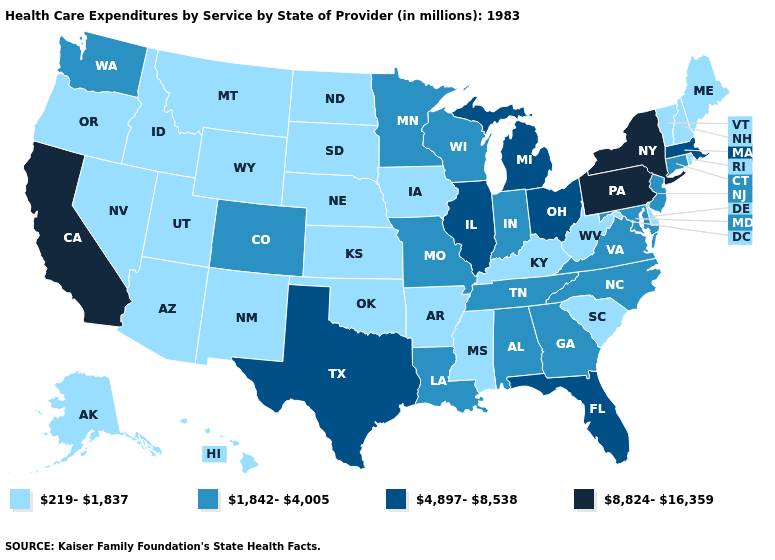What is the value of Utah?
Write a very short answer. 219-1,837. Name the states that have a value in the range 8,824-16,359?
Be succinct. California, New York, Pennsylvania. What is the value of Washington?
Keep it brief. 1,842-4,005. Does Massachusetts have the lowest value in the Northeast?
Quick response, please. No. Does Michigan have a higher value than Kansas?
Answer briefly. Yes. What is the value of Mississippi?
Concise answer only. 219-1,837. Which states hav the highest value in the South?
Short answer required. Florida, Texas. Which states hav the highest value in the Northeast?
Quick response, please. New York, Pennsylvania. Is the legend a continuous bar?
Quick response, please. No. Name the states that have a value in the range 4,897-8,538?
Quick response, please. Florida, Illinois, Massachusetts, Michigan, Ohio, Texas. What is the value of Arizona?
Be succinct. 219-1,837. What is the value of Idaho?
Be succinct. 219-1,837. Does New York have the highest value in the USA?
Give a very brief answer. Yes. Name the states that have a value in the range 219-1,837?
Give a very brief answer. Alaska, Arizona, Arkansas, Delaware, Hawaii, Idaho, Iowa, Kansas, Kentucky, Maine, Mississippi, Montana, Nebraska, Nevada, New Hampshire, New Mexico, North Dakota, Oklahoma, Oregon, Rhode Island, South Carolina, South Dakota, Utah, Vermont, West Virginia, Wyoming. Which states have the highest value in the USA?
Short answer required. California, New York, Pennsylvania. 